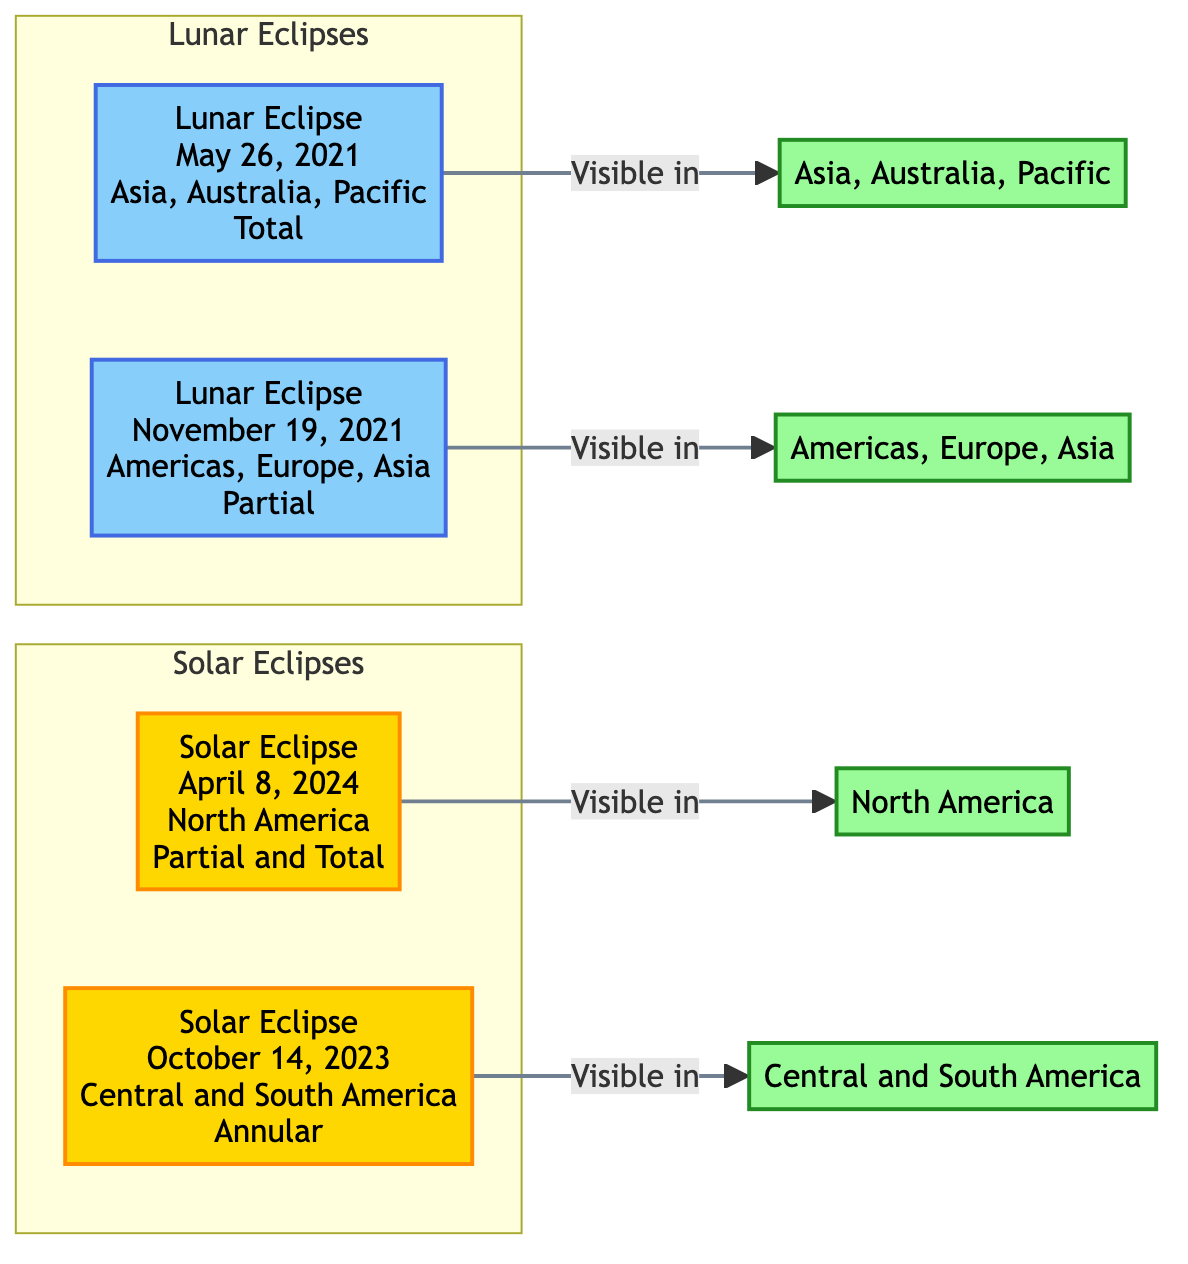What dates are marked for lunar eclipses in the diagram? There are two lunar eclipses shown: May 26, 2021, and November 19, 2021.
Answer: May 26, 2021; November 19, 2021 How many solar eclipses are represented? The diagram shows two solar eclipses: one on April 8, 2024, and another on October 14, 2023. Since only two are indicated, the count is straightforward.
Answer: 2 Which solar eclipse is visible in North America? The solar eclipse occurring on April 8, 2024, is specifically marked as being visible in North America. This is deduced from the direct connection made in the diagram.
Answer: April 8, 2024 What type of lunar eclipse occurs on November 19, 2021? The label for the lunar eclipse on November 19, 2021, states "Partial," allowing us to directly identify its type from the diagram.
Answer: Partial Which regions can observe the total lunar eclipse on May 26, 2021? The total lunar eclipse on May 26, 2021, is designated as being visible in Asia, Australia, and the Pacific. By reading the associated node, we can clearly ascertain the regions.
Answer: Asia, Australia, Pacific How does the diagram classify the eclipses? The diagram classifies eclipses into two categories: Solar Eclipses and Lunar Eclipses, with each type clearly separated in subgraphs. The visual layout allows us to differentiate between the two.
Answer: Solar and Lunar Eclipses What is the visibility condition for the solar eclipse on October 14, 2023? The solar eclipse on October 14, 2023, is classified as "Annular" and is marked to be visible in Central and South America, which can be seen from the direct connection in the diagram.
Answer: Annular Which type of eclipse is visible in the Americas on November 19, 2021? The eclipse on this date is noted as a "Partial" lunar eclipse, making it clear through the information presented in the diagram that this is the type observed in the Americas.
Answer: Partial 